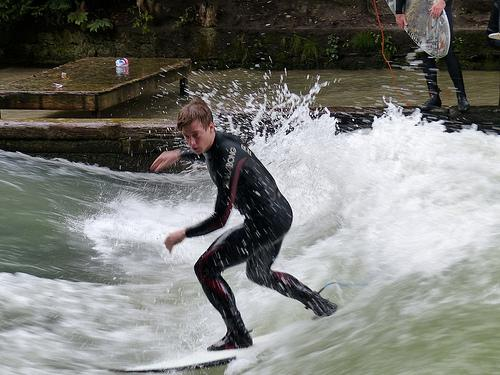Question: how many people are shown?
Choices:
A. 4.
B. 2.
C. 5.
D. 6.
Answer with the letter. Answer: B Question: what is the person on the surfboard wearing?
Choices:
A. Speedo suit.
B. Wetsuit.
C. Strapless shirt.
D. Bikini.
Answer with the letter. Answer: B Question: what color string is coming from the surfer's ankle?
Choices:
A. Red.
B. White.
C. Blue.
D. Black.
Answer with the letter. Answer: C Question: where was the photo taken?
Choices:
A. Waves.
B. Ocean.
C. Beach.
D. Sand.
Answer with the letter. Answer: B Question: when was the photo taken?
Choices:
A. Daytime.
B. Afternoon.
C. Evening.
D. Dusk.
Answer with the letter. Answer: A 